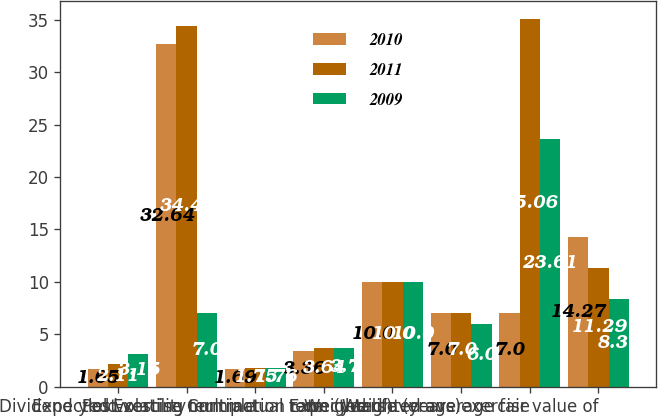<chart> <loc_0><loc_0><loc_500><loc_500><stacked_bar_chart><ecel><fcel>Dividend yield<fcel>Expected volatility<fcel>Exercise multiple<fcel>Post-vesting termination rate<fcel>Contractual term (years)<fcel>Expected life (years)<fcel>Weighted average exercise<fcel>Weighted average fair value of<nl><fcel>2010<fcel>1.65<fcel>32.64<fcel>1.69<fcel>3.36<fcel>10<fcel>7<fcel>7<fcel>14.27<nl><fcel>2011<fcel>2.11<fcel>34.41<fcel>1.75<fcel>3.64<fcel>10<fcel>7<fcel>35.06<fcel>11.29<nl><fcel>2009<fcel>3.15<fcel>7<fcel>1.76<fcel>3.7<fcel>10<fcel>6<fcel>23.61<fcel>8.37<nl></chart> 